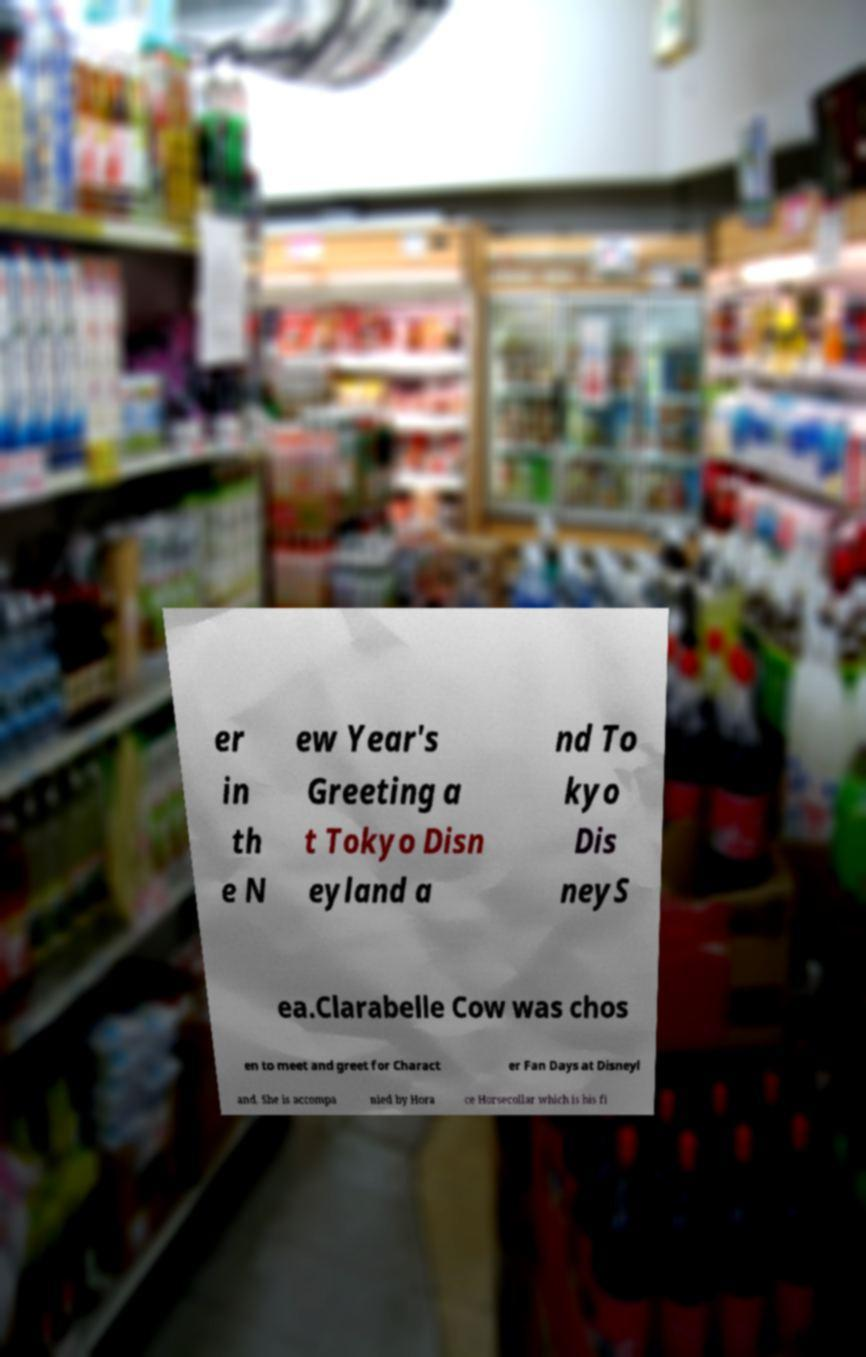There's text embedded in this image that I need extracted. Can you transcribe it verbatim? er in th e N ew Year's Greeting a t Tokyo Disn eyland a nd To kyo Dis neyS ea.Clarabelle Cow was chos en to meet and greet for Charact er Fan Days at Disneyl and. She is accompa nied by Hora ce Horsecollar which is his fi 